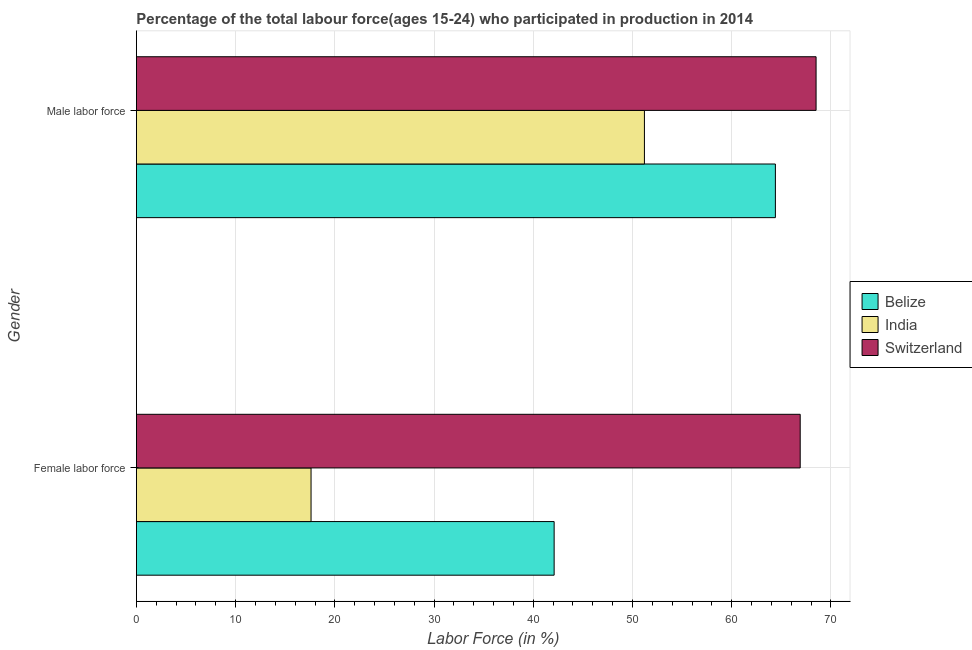How many different coloured bars are there?
Offer a very short reply. 3. How many groups of bars are there?
Offer a terse response. 2. Are the number of bars on each tick of the Y-axis equal?
Make the answer very short. Yes. What is the label of the 1st group of bars from the top?
Provide a short and direct response. Male labor force. What is the percentage of male labour force in Switzerland?
Your response must be concise. 68.5. Across all countries, what is the maximum percentage of female labor force?
Provide a succinct answer. 66.9. Across all countries, what is the minimum percentage of male labour force?
Your response must be concise. 51.2. In which country was the percentage of male labour force maximum?
Offer a very short reply. Switzerland. What is the total percentage of female labor force in the graph?
Your response must be concise. 126.6. What is the difference between the percentage of male labour force in India and that in Belize?
Offer a terse response. -13.2. What is the difference between the percentage of female labor force in India and the percentage of male labour force in Switzerland?
Your response must be concise. -50.9. What is the average percentage of male labour force per country?
Your response must be concise. 61.37. What is the difference between the percentage of male labour force and percentage of female labor force in Switzerland?
Provide a succinct answer. 1.6. What is the ratio of the percentage of female labor force in Switzerland to that in Belize?
Provide a short and direct response. 1.59. In how many countries, is the percentage of male labour force greater than the average percentage of male labour force taken over all countries?
Your answer should be very brief. 2. What does the 1st bar from the top in Female labor force represents?
Offer a terse response. Switzerland. What does the 3rd bar from the bottom in Male labor force represents?
Provide a succinct answer. Switzerland. How many bars are there?
Give a very brief answer. 6. Does the graph contain any zero values?
Your answer should be compact. No. Where does the legend appear in the graph?
Keep it short and to the point. Center right. What is the title of the graph?
Your answer should be compact. Percentage of the total labour force(ages 15-24) who participated in production in 2014. What is the label or title of the Y-axis?
Your response must be concise. Gender. What is the Labor Force (in %) in Belize in Female labor force?
Your answer should be compact. 42.1. What is the Labor Force (in %) of India in Female labor force?
Keep it short and to the point. 17.6. What is the Labor Force (in %) of Switzerland in Female labor force?
Offer a very short reply. 66.9. What is the Labor Force (in %) in Belize in Male labor force?
Keep it short and to the point. 64.4. What is the Labor Force (in %) of India in Male labor force?
Your answer should be compact. 51.2. What is the Labor Force (in %) of Switzerland in Male labor force?
Offer a very short reply. 68.5. Across all Gender, what is the maximum Labor Force (in %) of Belize?
Make the answer very short. 64.4. Across all Gender, what is the maximum Labor Force (in %) in India?
Provide a short and direct response. 51.2. Across all Gender, what is the maximum Labor Force (in %) of Switzerland?
Ensure brevity in your answer.  68.5. Across all Gender, what is the minimum Labor Force (in %) of Belize?
Provide a short and direct response. 42.1. Across all Gender, what is the minimum Labor Force (in %) of India?
Keep it short and to the point. 17.6. Across all Gender, what is the minimum Labor Force (in %) of Switzerland?
Provide a short and direct response. 66.9. What is the total Labor Force (in %) in Belize in the graph?
Your response must be concise. 106.5. What is the total Labor Force (in %) of India in the graph?
Provide a short and direct response. 68.8. What is the total Labor Force (in %) in Switzerland in the graph?
Provide a short and direct response. 135.4. What is the difference between the Labor Force (in %) of Belize in Female labor force and that in Male labor force?
Your answer should be very brief. -22.3. What is the difference between the Labor Force (in %) in India in Female labor force and that in Male labor force?
Make the answer very short. -33.6. What is the difference between the Labor Force (in %) in Belize in Female labor force and the Labor Force (in %) in Switzerland in Male labor force?
Provide a succinct answer. -26.4. What is the difference between the Labor Force (in %) in India in Female labor force and the Labor Force (in %) in Switzerland in Male labor force?
Your answer should be compact. -50.9. What is the average Labor Force (in %) of Belize per Gender?
Your response must be concise. 53.25. What is the average Labor Force (in %) of India per Gender?
Your answer should be very brief. 34.4. What is the average Labor Force (in %) of Switzerland per Gender?
Your answer should be compact. 67.7. What is the difference between the Labor Force (in %) in Belize and Labor Force (in %) in Switzerland in Female labor force?
Keep it short and to the point. -24.8. What is the difference between the Labor Force (in %) of India and Labor Force (in %) of Switzerland in Female labor force?
Ensure brevity in your answer.  -49.3. What is the difference between the Labor Force (in %) of India and Labor Force (in %) of Switzerland in Male labor force?
Your answer should be very brief. -17.3. What is the ratio of the Labor Force (in %) in Belize in Female labor force to that in Male labor force?
Offer a terse response. 0.65. What is the ratio of the Labor Force (in %) in India in Female labor force to that in Male labor force?
Your response must be concise. 0.34. What is the ratio of the Labor Force (in %) of Switzerland in Female labor force to that in Male labor force?
Your response must be concise. 0.98. What is the difference between the highest and the second highest Labor Force (in %) in Belize?
Offer a terse response. 22.3. What is the difference between the highest and the second highest Labor Force (in %) in India?
Keep it short and to the point. 33.6. What is the difference between the highest and the second highest Labor Force (in %) in Switzerland?
Your response must be concise. 1.6. What is the difference between the highest and the lowest Labor Force (in %) in Belize?
Keep it short and to the point. 22.3. What is the difference between the highest and the lowest Labor Force (in %) of India?
Offer a terse response. 33.6. What is the difference between the highest and the lowest Labor Force (in %) in Switzerland?
Provide a succinct answer. 1.6. 